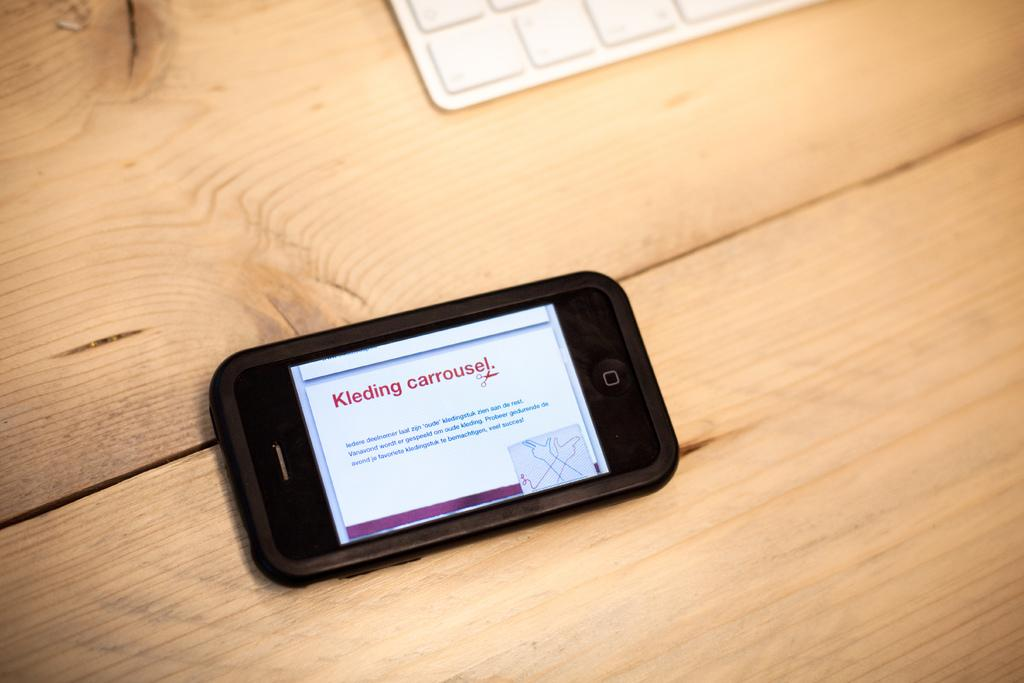<image>
Offer a succinct explanation of the picture presented. a cell phone with the words kleding carrouse on it in red 